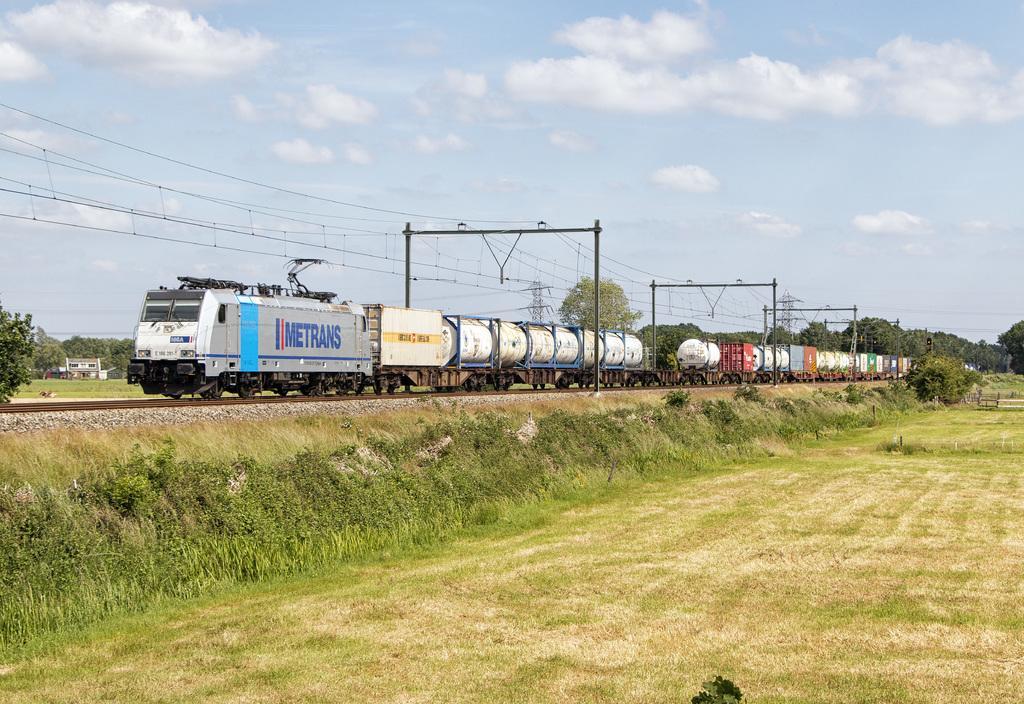Could you give a brief overview of what you see in this image? In this image I can see the train on the track. The train is colorful and something is written on it. To the side of the rain I can see the poles and many trees. In the background there are clouds and the sky. 